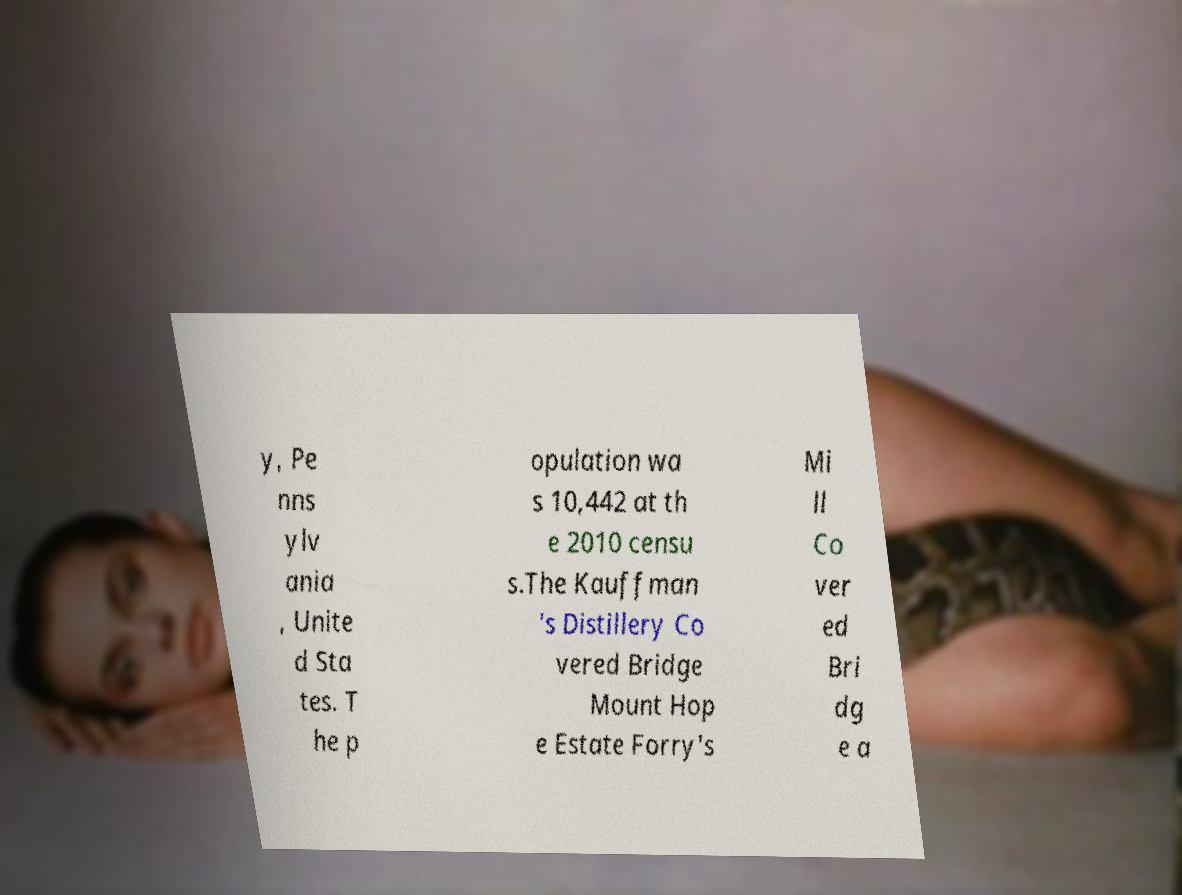Please identify and transcribe the text found in this image. y, Pe nns ylv ania , Unite d Sta tes. T he p opulation wa s 10,442 at th e 2010 censu s.The Kauffman 's Distillery Co vered Bridge Mount Hop e Estate Forry's Mi ll Co ver ed Bri dg e a 